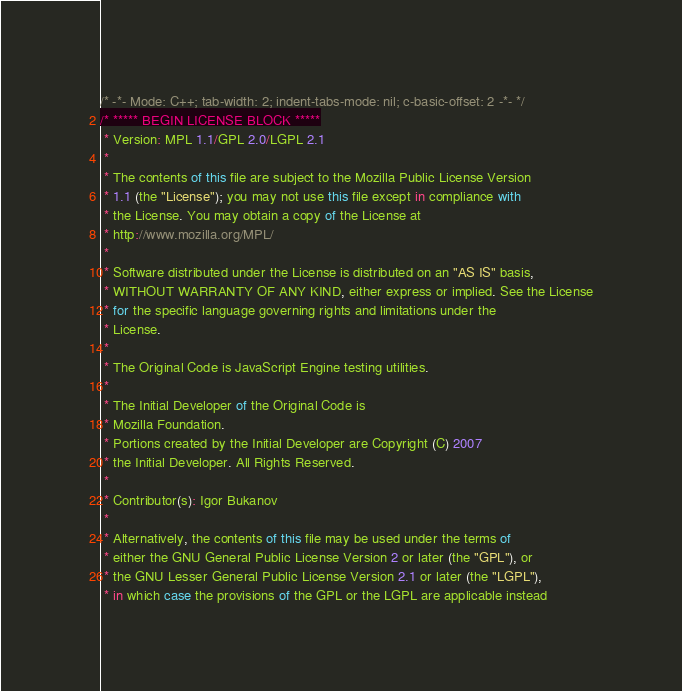<code> <loc_0><loc_0><loc_500><loc_500><_JavaScript_>/* -*- Mode: C++; tab-width: 2; indent-tabs-mode: nil; c-basic-offset: 2 -*- */
/* ***** BEGIN LICENSE BLOCK *****
 * Version: MPL 1.1/GPL 2.0/LGPL 2.1
 *
 * The contents of this file are subject to the Mozilla Public License Version
 * 1.1 (the "License"); you may not use this file except in compliance with
 * the License. You may obtain a copy of the License at
 * http://www.mozilla.org/MPL/
 *
 * Software distributed under the License is distributed on an "AS IS" basis,
 * WITHOUT WARRANTY OF ANY KIND, either express or implied. See the License
 * for the specific language governing rights and limitations under the
 * License.
 *
 * The Original Code is JavaScript Engine testing utilities.
 *
 * The Initial Developer of the Original Code is
 * Mozilla Foundation.
 * Portions created by the Initial Developer are Copyright (C) 2007
 * the Initial Developer. All Rights Reserved.
 *
 * Contributor(s): Igor Bukanov
 *
 * Alternatively, the contents of this file may be used under the terms of
 * either the GNU General Public License Version 2 or later (the "GPL"), or
 * the GNU Lesser General Public License Version 2.1 or later (the "LGPL"),
 * in which case the provisions of the GPL or the LGPL are applicable instead</code> 